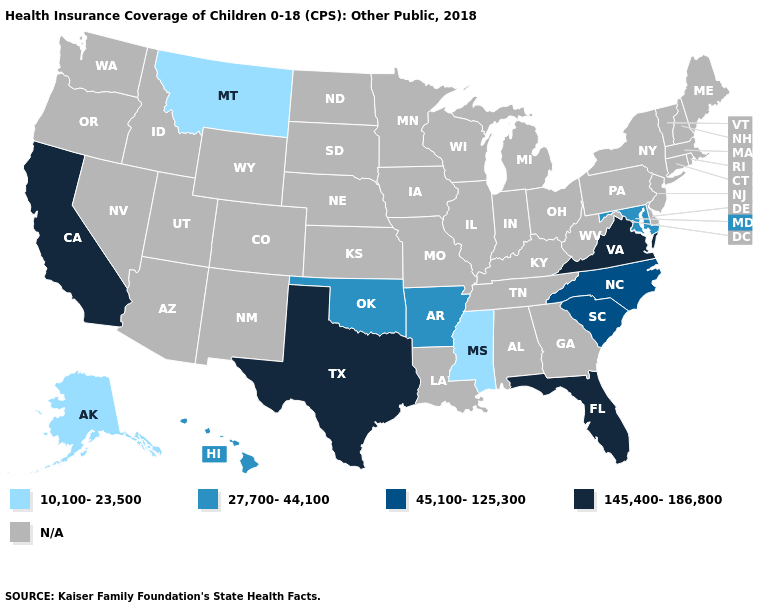Does the map have missing data?
Concise answer only. Yes. How many symbols are there in the legend?
Quick response, please. 5. What is the value of Massachusetts?
Concise answer only. N/A. Name the states that have a value in the range 145,400-186,800?
Short answer required. California, Florida, Texas, Virginia. How many symbols are there in the legend?
Keep it brief. 5. What is the highest value in the South ?
Write a very short answer. 145,400-186,800. What is the value of Louisiana?
Give a very brief answer. N/A. How many symbols are there in the legend?
Short answer required. 5. What is the lowest value in states that border Pennsylvania?
Write a very short answer. 27,700-44,100. What is the highest value in the USA?
Quick response, please. 145,400-186,800. What is the lowest value in states that border Wyoming?
Give a very brief answer. 10,100-23,500. Does the map have missing data?
Be succinct. Yes. What is the value of California?
Short answer required. 145,400-186,800. 